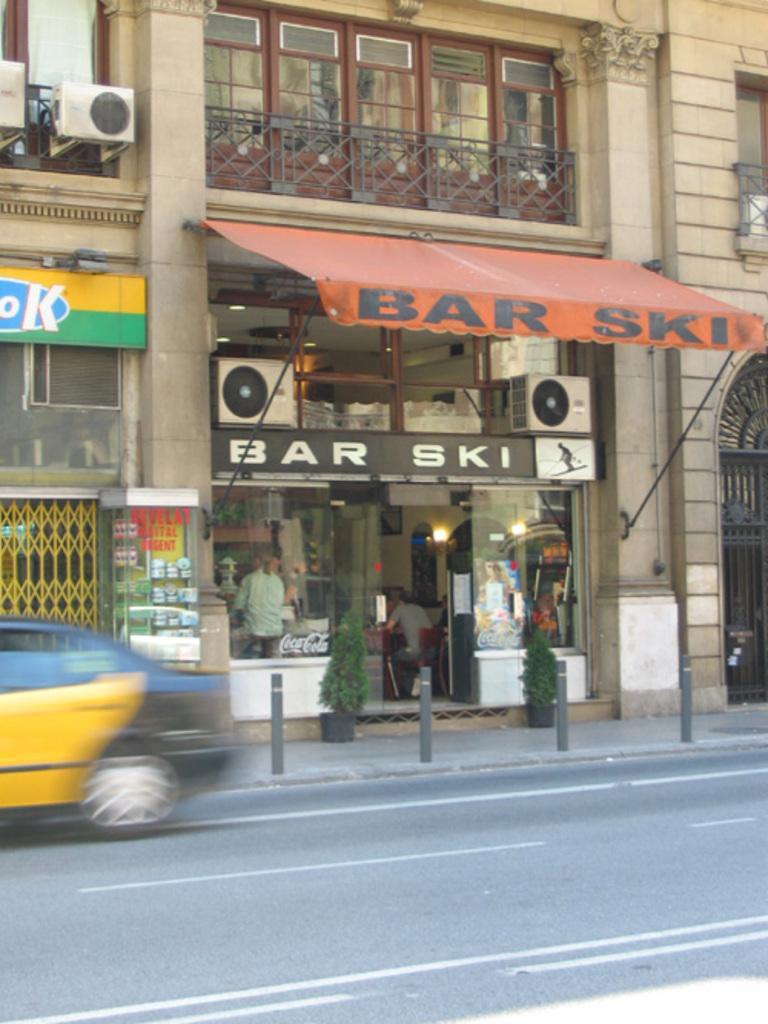Can you describe this image briefly? We can see car on the road and poles. We can see building, railings, windows, door, grills, store, AC outlet, board, house plants, objects in glass stand and glass, through this glass we can see people. 